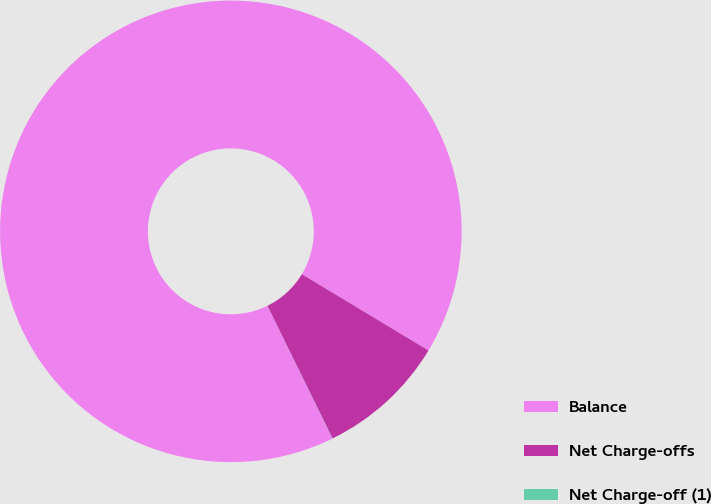Convert chart. <chart><loc_0><loc_0><loc_500><loc_500><pie_chart><fcel>Balance<fcel>Net Charge-offs<fcel>Net Charge-off (1)<nl><fcel>90.89%<fcel>9.1%<fcel>0.01%<nl></chart> 